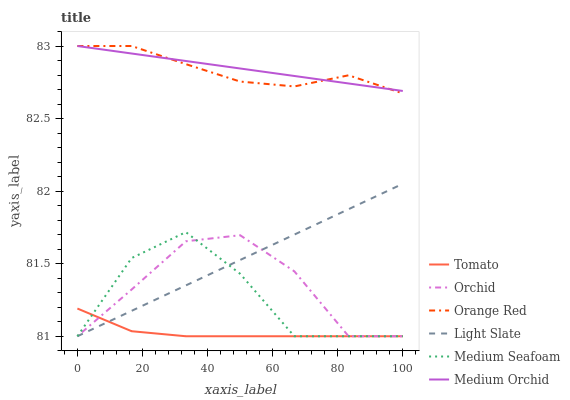Does Tomato have the minimum area under the curve?
Answer yes or no. Yes. Does Medium Orchid have the maximum area under the curve?
Answer yes or no. Yes. Does Light Slate have the minimum area under the curve?
Answer yes or no. No. Does Light Slate have the maximum area under the curve?
Answer yes or no. No. Is Medium Orchid the smoothest?
Answer yes or no. Yes. Is Medium Seafoam the roughest?
Answer yes or no. Yes. Is Light Slate the smoothest?
Answer yes or no. No. Is Light Slate the roughest?
Answer yes or no. No. Does Medium Orchid have the lowest value?
Answer yes or no. No. Does Orange Red have the highest value?
Answer yes or no. Yes. Does Light Slate have the highest value?
Answer yes or no. No. Is Medium Seafoam less than Medium Orchid?
Answer yes or no. Yes. Is Medium Orchid greater than Medium Seafoam?
Answer yes or no. Yes. Does Tomato intersect Medium Seafoam?
Answer yes or no. Yes. Is Tomato less than Medium Seafoam?
Answer yes or no. No. Is Tomato greater than Medium Seafoam?
Answer yes or no. No. Does Medium Seafoam intersect Medium Orchid?
Answer yes or no. No. 